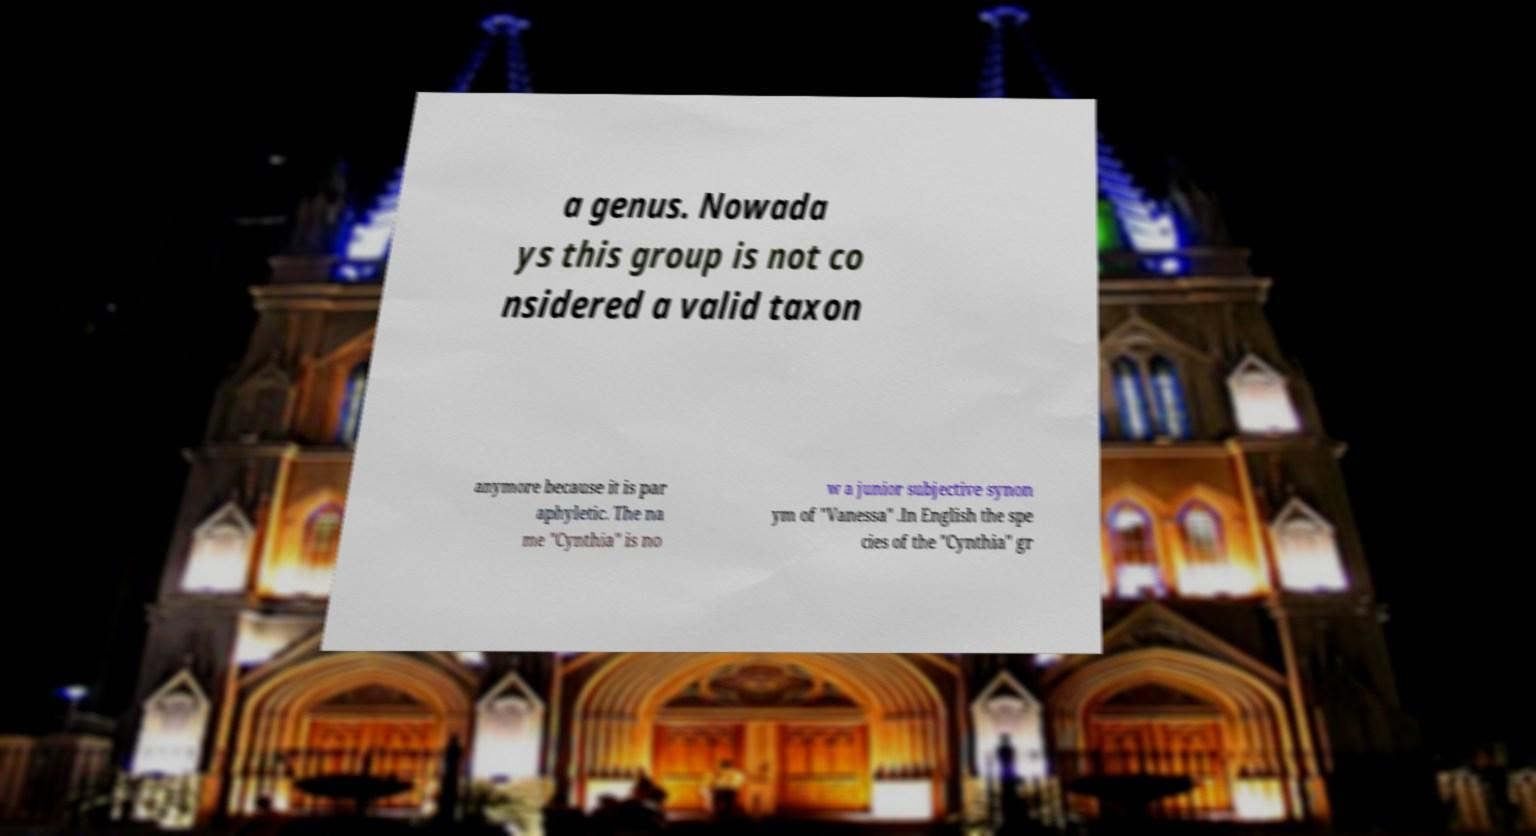There's text embedded in this image that I need extracted. Can you transcribe it verbatim? a genus. Nowada ys this group is not co nsidered a valid taxon anymore because it is par aphyletic. The na me "Cynthia" is no w a junior subjective synon ym of "Vanessa" .In English the spe cies of the "Cynthia" gr 